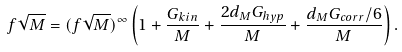Convert formula to latex. <formula><loc_0><loc_0><loc_500><loc_500>f \sqrt { M } = ( f \sqrt { M } ) ^ { \infty } \left ( 1 + \frac { G _ { k i n } } { M } + \frac { 2 d _ { M } G _ { h y p } } { M } + \frac { d _ { M } G _ { c o r r } / 6 } { M } \right ) .</formula> 